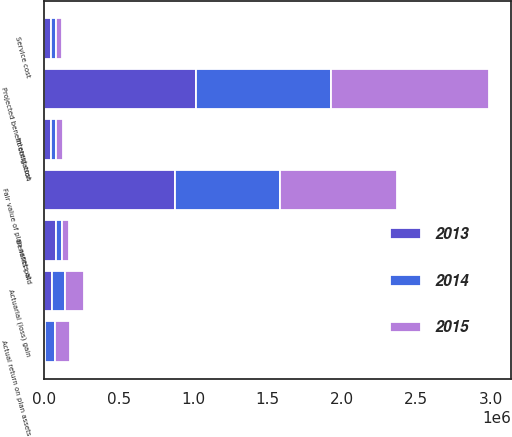<chart> <loc_0><loc_0><loc_500><loc_500><stacked_bar_chart><ecel><fcel>Projected benefit obligation<fcel>Service cost<fcel>Interest cost<fcel>Actuarial (loss) gain<fcel>Benefits paid<fcel>Fair value of plan assets at<fcel>Actual return on plan assets<nl><fcel>2013<fcel>1.01859e+06<fcel>41989<fcel>41766<fcel>52201<fcel>77002<fcel>879211<fcel>5458<nl><fcel>2015<fcel>1.06404e+06<fcel>36609<fcel>43613<fcel>127940<fcel>50063<fcel>786750<fcel>102628<nl><fcel>2014<fcel>905943<fcel>38580<fcel>38243<fcel>89029<fcel>38023<fcel>704976<fcel>64641<nl></chart> 